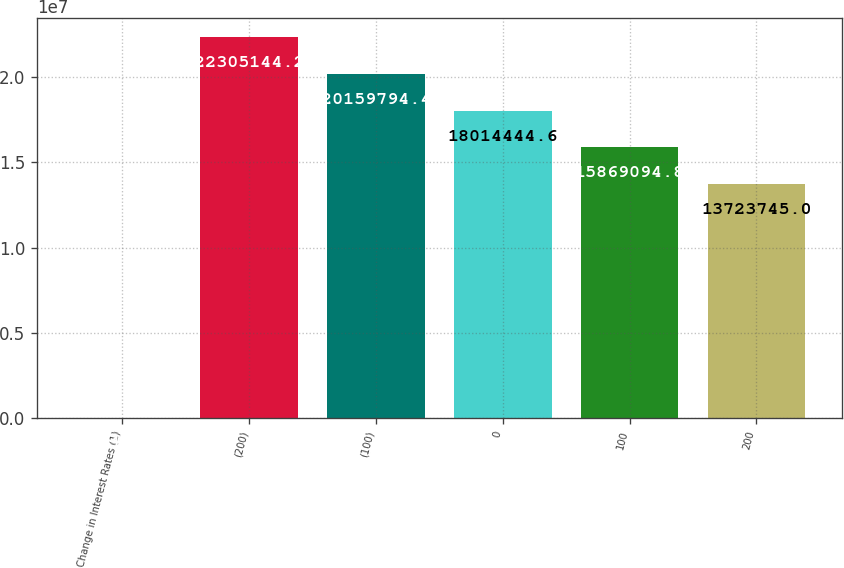Convert chart to OTSL. <chart><loc_0><loc_0><loc_500><loc_500><bar_chart><fcel>Change in Interest Rates (1)<fcel>(200)<fcel>(100)<fcel>0<fcel>100<fcel>200<nl><fcel>2017<fcel>2.23051e+07<fcel>2.01598e+07<fcel>1.80144e+07<fcel>1.58691e+07<fcel>1.37237e+07<nl></chart> 